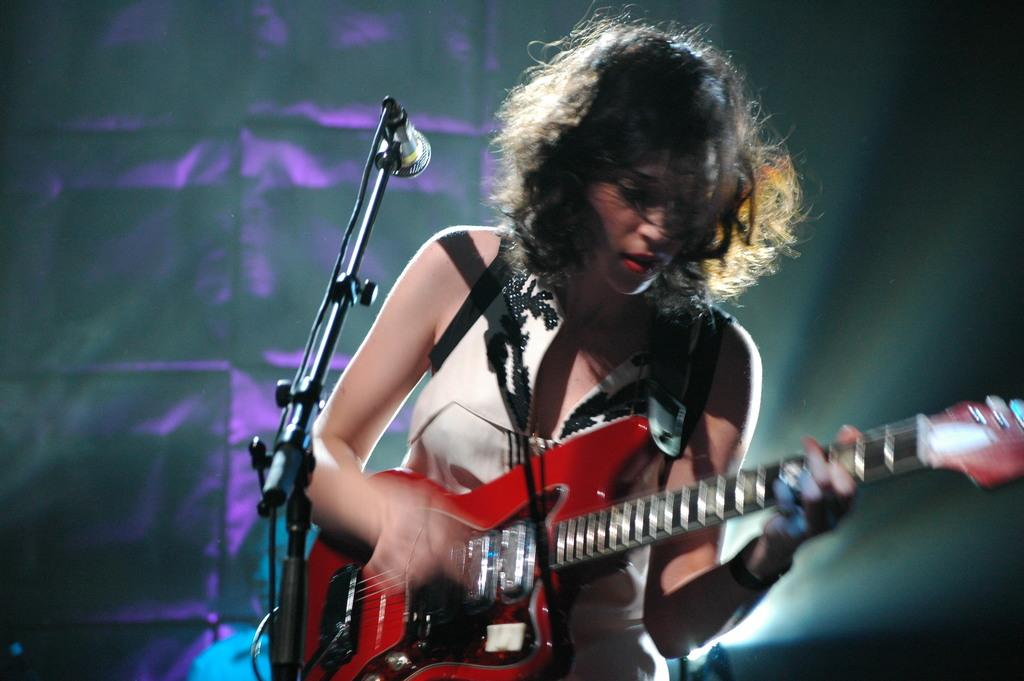Who is the main subject in the image? There is a girl in the image. What is the girl doing in the image? The girl is playing a guitar. What object is in front of the girl? There is a microphone in front of the girl. What color is the screen behind the girl? The screen behind the girl is violet-colored. How does the snail contribute to the girl's performance in the image? There is no snail present in the image, so it cannot contribute to the girl's performance. 